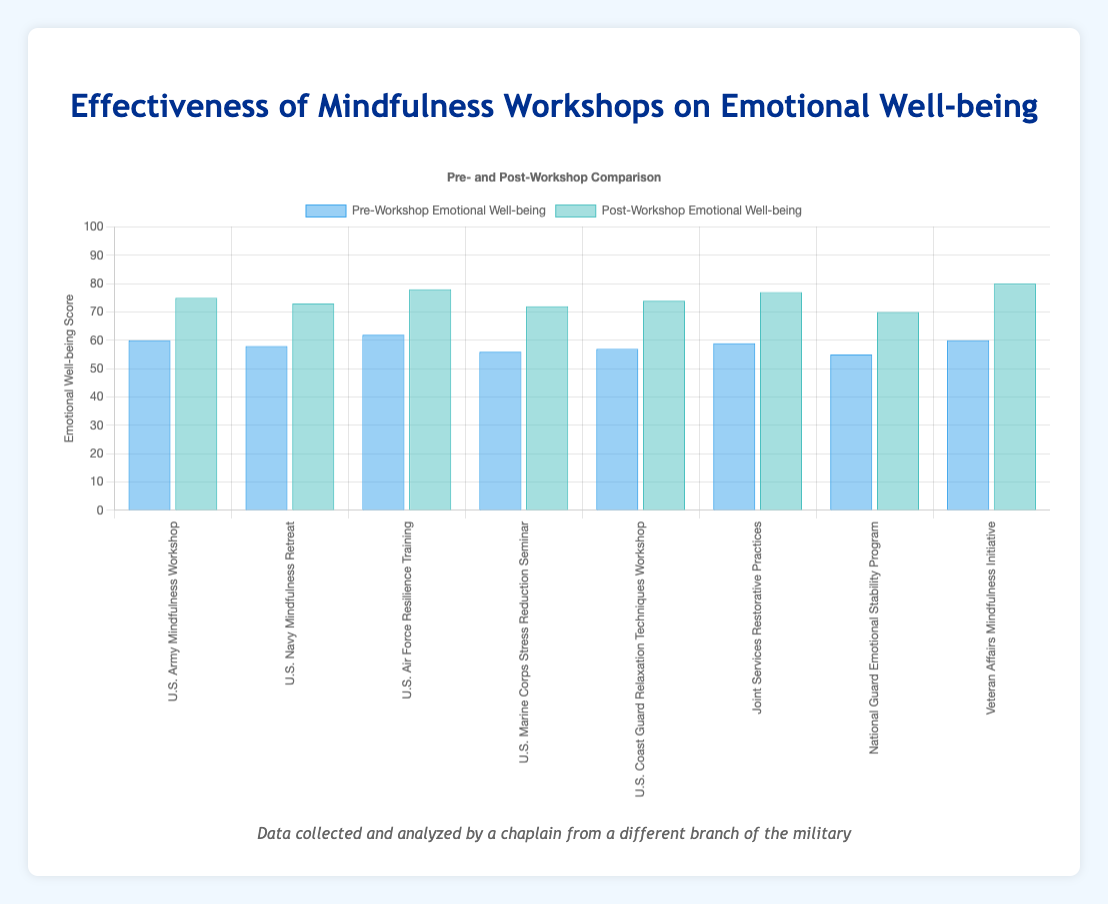Which workshop showed the greatest improvement in emotional well-being? To find the greatest improvement, subtract the pre-workshop score from the post-workshop score for each workshop. The Veteran Affairs Mindfulness Initiative showed the greatest improvement with an increase of 20 points (80 - 60).
Answer: Veteran Affairs Mindfulness Initiative Which workshop had the lowest pre-workshop emotional well-being score? Look at the pre-workshop scores on the chart and find the lowest value, which is 55 for the National Guard Emotional Stability Program.
Answer: National Guard Emotional Stability Program How much did the emotional well-being score improve for the U.S. Marine Corps Stress Reduction Seminar? Subtract the pre-workshop score (56) from the post-workshop score (72) to find the improvement. 72 - 56 = 16.
Answer: 16 Between the U.S. Navy Mindfulness Retreat and the Joint Services Restorative Practices, which had a higher post-workshop score? Compare the post-workshop scores of the two workshops: U.S. Navy Mindfulness Retreat (73) and Joint Services Restorative Practices (77). The Joint Services Restorative Practices had a higher score.
Answer: Joint Services Restorative Practices Which workshop had the highest post-workshop emotional well-being score? Look at the post-workshop scores on the chart and find the highest value, which is 80 for the Veteran Affairs Mindfulness Initiative.
Answer: Veteran Affairs Mindfulness Initiative What is the average pre-workshop emotional well-being score across all workshops? Sum all pre-workshop scores (60 + 58 + 62 + 56 + 57 + 59 + 55 + 60 = 467) and divide by the number of workshops (8). 467 / 8 = 58.375, approximately 58.4.
Answer: 58.4 Which workshop had a higher increase in emotional well-being: the U.S. Air Force Resilience Training or the U.S. Coast Guard Relaxation Techniques Workshop? Calculate the increase for both workshops: U.S. Air Force (78 - 62 = 16) and U.S. Coast Guard (74 - 57 = 17). The U.S. Coast Guard Relaxation Techniques Workshop had a higher increase by 1 point.
Answer: U.S. Coast Guard Relaxation Techniques Workshop What is the total increase in emotional well-being scores for all workshops combined? Sum the individual increases for each workshop: (75-60) + (73-58) + (78-62) + (72-56) + (74-57) + (77-59) + (70-55) + (80-60) = 15 + 15 + 16 + 16 + 17 + 18 + 15 + 20 = 132.
Answer: 132 What is the difference in pre-workshop emotional well-being scores between the highest and lowest scoring workshops? Identify the highest and lowest pre-workshop scores: highest is 62 (U.S. Air Force Resilience Training) and lowest is 55 (National Guard Emotional Stability Program). The difference is 62 - 55 = 7.
Answer: 7 